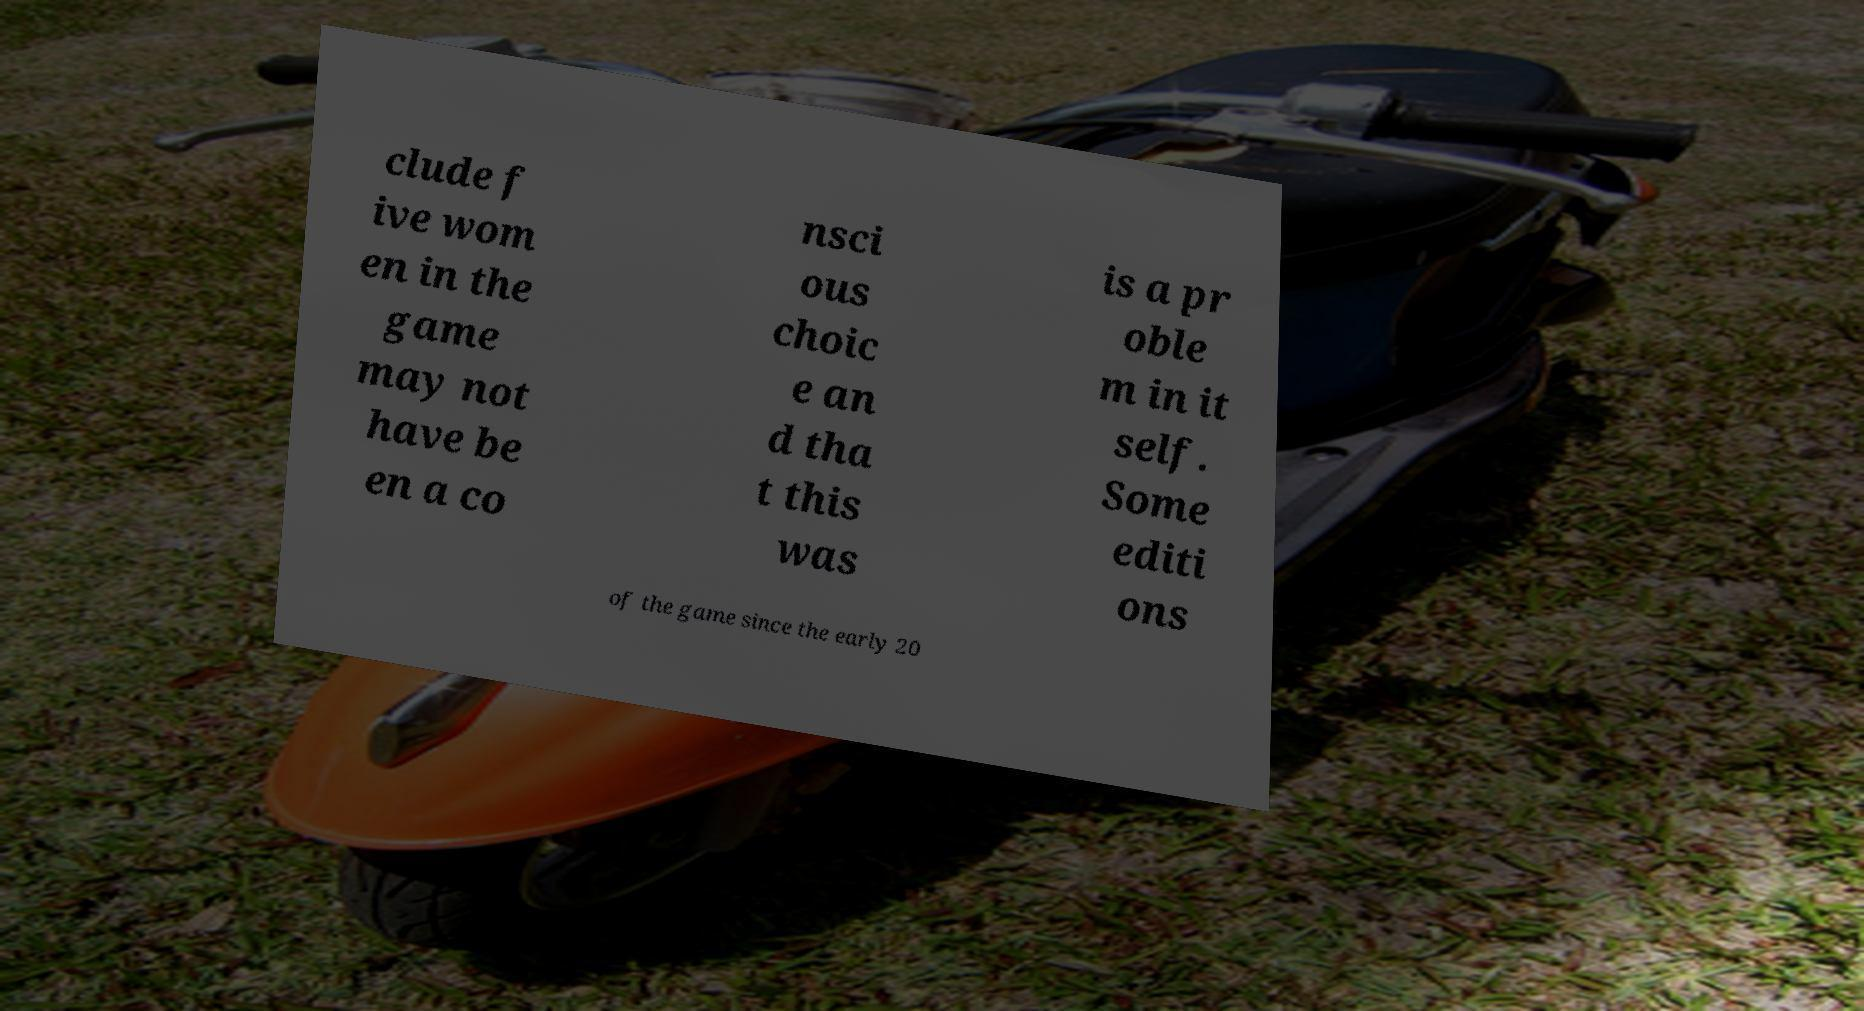What messages or text are displayed in this image? I need them in a readable, typed format. clude f ive wom en in the game may not have be en a co nsci ous choic e an d tha t this was is a pr oble m in it self. Some editi ons of the game since the early 20 